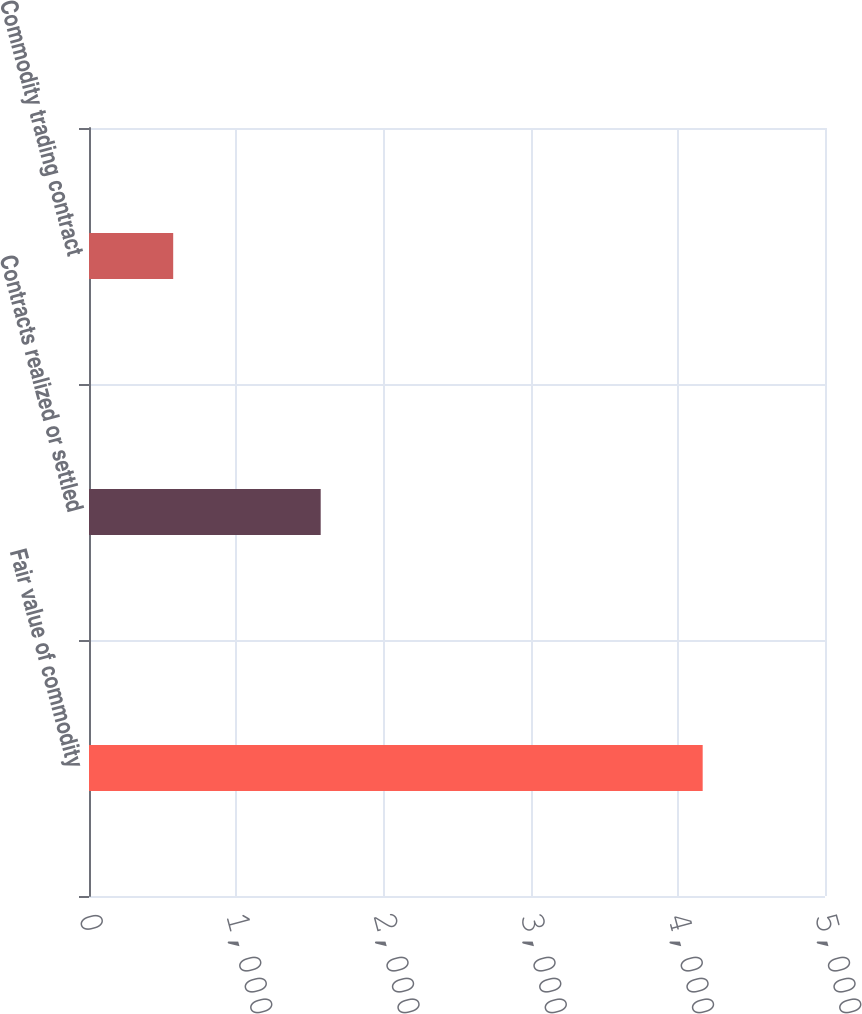Convert chart. <chart><loc_0><loc_0><loc_500><loc_500><bar_chart><fcel>Fair value of commodity<fcel>Contracts realized or settled<fcel>Commodity trading contract<nl><fcel>4169<fcel>1574<fcel>572<nl></chart> 